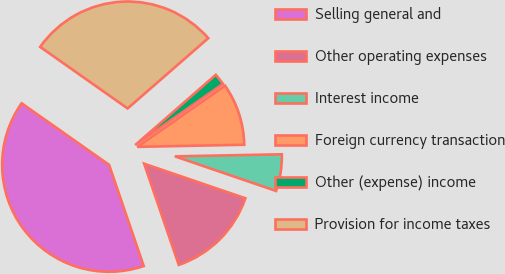Convert chart. <chart><loc_0><loc_0><loc_500><loc_500><pie_chart><fcel>Selling general and<fcel>Other operating expenses<fcel>Interest income<fcel>Foreign currency transaction<fcel>Other (expense) income<fcel>Provision for income taxes<nl><fcel>40.01%<fcel>14.51%<fcel>5.55%<fcel>9.38%<fcel>1.72%<fcel>28.83%<nl></chart> 